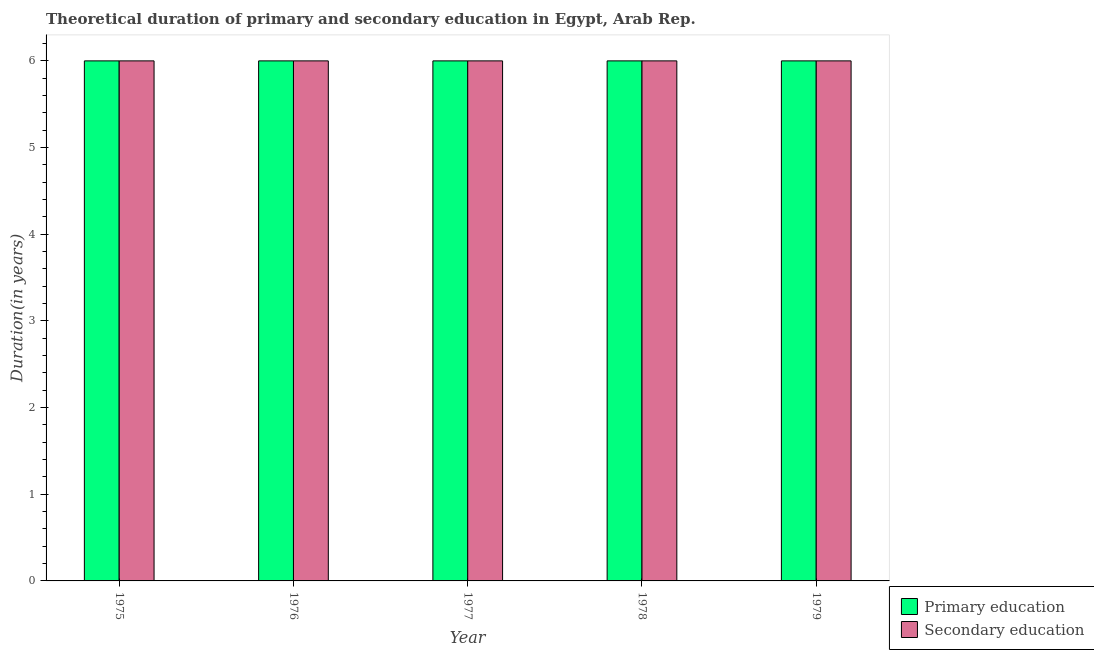How many groups of bars are there?
Your answer should be very brief. 5. Are the number of bars per tick equal to the number of legend labels?
Ensure brevity in your answer.  Yes. Are the number of bars on each tick of the X-axis equal?
Offer a very short reply. Yes. How many bars are there on the 3rd tick from the left?
Your answer should be very brief. 2. What is the label of the 2nd group of bars from the left?
Your answer should be compact. 1976. In how many cases, is the number of bars for a given year not equal to the number of legend labels?
Your answer should be very brief. 0. Across all years, what is the maximum duration of primary education?
Make the answer very short. 6. Across all years, what is the minimum duration of secondary education?
Make the answer very short. 6. In which year was the duration of secondary education maximum?
Ensure brevity in your answer.  1975. In which year was the duration of secondary education minimum?
Your answer should be very brief. 1975. What is the total duration of primary education in the graph?
Make the answer very short. 30. What is the difference between the duration of primary education in 1976 and that in 1978?
Offer a terse response. 0. What is the average duration of primary education per year?
Provide a short and direct response. 6. In the year 1978, what is the difference between the duration of primary education and duration of secondary education?
Provide a succinct answer. 0. What is the ratio of the duration of secondary education in 1977 to that in 1978?
Offer a very short reply. 1. Is the difference between the duration of primary education in 1975 and 1979 greater than the difference between the duration of secondary education in 1975 and 1979?
Your answer should be compact. No. What is the difference between the highest and the second highest duration of secondary education?
Offer a terse response. 0. In how many years, is the duration of primary education greater than the average duration of primary education taken over all years?
Your answer should be compact. 0. Is the sum of the duration of primary education in 1975 and 1976 greater than the maximum duration of secondary education across all years?
Your response must be concise. Yes. What does the 2nd bar from the left in 1979 represents?
Keep it short and to the point. Secondary education. Are all the bars in the graph horizontal?
Provide a short and direct response. No. How many years are there in the graph?
Offer a very short reply. 5. Does the graph contain any zero values?
Keep it short and to the point. No. Where does the legend appear in the graph?
Give a very brief answer. Bottom right. How are the legend labels stacked?
Your response must be concise. Vertical. What is the title of the graph?
Keep it short and to the point. Theoretical duration of primary and secondary education in Egypt, Arab Rep. What is the label or title of the X-axis?
Your answer should be compact. Year. What is the label or title of the Y-axis?
Make the answer very short. Duration(in years). What is the Duration(in years) of Secondary education in 1975?
Keep it short and to the point. 6. What is the Duration(in years) in Secondary education in 1978?
Keep it short and to the point. 6. What is the Duration(in years) of Primary education in 1979?
Your answer should be very brief. 6. What is the Duration(in years) of Secondary education in 1979?
Provide a succinct answer. 6. Across all years, what is the maximum Duration(in years) of Secondary education?
Offer a very short reply. 6. Across all years, what is the minimum Duration(in years) of Primary education?
Your answer should be compact. 6. What is the difference between the Duration(in years) in Primary education in 1975 and that in 1976?
Keep it short and to the point. 0. What is the difference between the Duration(in years) in Secondary education in 1975 and that in 1976?
Your answer should be very brief. 0. What is the difference between the Duration(in years) of Primary education in 1975 and that in 1978?
Provide a succinct answer. 0. What is the difference between the Duration(in years) of Secondary education in 1975 and that in 1978?
Give a very brief answer. 0. What is the difference between the Duration(in years) of Primary education in 1975 and that in 1979?
Your answer should be compact. 0. What is the difference between the Duration(in years) in Secondary education in 1975 and that in 1979?
Provide a succinct answer. 0. What is the difference between the Duration(in years) in Primary education in 1976 and that in 1977?
Your answer should be compact. 0. What is the difference between the Duration(in years) in Primary education in 1976 and that in 1978?
Your response must be concise. 0. What is the difference between the Duration(in years) in Primary education in 1976 and that in 1979?
Offer a terse response. 0. What is the difference between the Duration(in years) of Secondary education in 1977 and that in 1978?
Ensure brevity in your answer.  0. What is the difference between the Duration(in years) of Secondary education in 1977 and that in 1979?
Your answer should be very brief. 0. What is the difference between the Duration(in years) of Primary education in 1975 and the Duration(in years) of Secondary education in 1976?
Your response must be concise. 0. What is the difference between the Duration(in years) in Primary education in 1975 and the Duration(in years) in Secondary education in 1978?
Keep it short and to the point. 0. What is the difference between the Duration(in years) in Primary education in 1975 and the Duration(in years) in Secondary education in 1979?
Give a very brief answer. 0. What is the difference between the Duration(in years) of Primary education in 1976 and the Duration(in years) of Secondary education in 1977?
Make the answer very short. 0. What is the difference between the Duration(in years) of Primary education in 1976 and the Duration(in years) of Secondary education in 1978?
Give a very brief answer. 0. What is the difference between the Duration(in years) in Primary education in 1978 and the Duration(in years) in Secondary education in 1979?
Provide a short and direct response. 0. What is the average Duration(in years) of Primary education per year?
Your answer should be compact. 6. What is the average Duration(in years) in Secondary education per year?
Provide a succinct answer. 6. In the year 1976, what is the difference between the Duration(in years) of Primary education and Duration(in years) of Secondary education?
Ensure brevity in your answer.  0. In the year 1977, what is the difference between the Duration(in years) in Primary education and Duration(in years) in Secondary education?
Your answer should be compact. 0. In the year 1978, what is the difference between the Duration(in years) in Primary education and Duration(in years) in Secondary education?
Give a very brief answer. 0. What is the ratio of the Duration(in years) of Secondary education in 1975 to that in 1977?
Give a very brief answer. 1. What is the ratio of the Duration(in years) in Primary education in 1975 to that in 1978?
Provide a short and direct response. 1. What is the ratio of the Duration(in years) of Secondary education in 1975 to that in 1978?
Provide a short and direct response. 1. What is the ratio of the Duration(in years) in Primary education in 1975 to that in 1979?
Keep it short and to the point. 1. What is the ratio of the Duration(in years) of Secondary education in 1975 to that in 1979?
Provide a succinct answer. 1. What is the ratio of the Duration(in years) in Primary education in 1976 to that in 1979?
Your answer should be compact. 1. What is the difference between the highest and the second highest Duration(in years) of Primary education?
Your answer should be very brief. 0. What is the difference between the highest and the second highest Duration(in years) of Secondary education?
Your response must be concise. 0. What is the difference between the highest and the lowest Duration(in years) of Secondary education?
Provide a short and direct response. 0. 